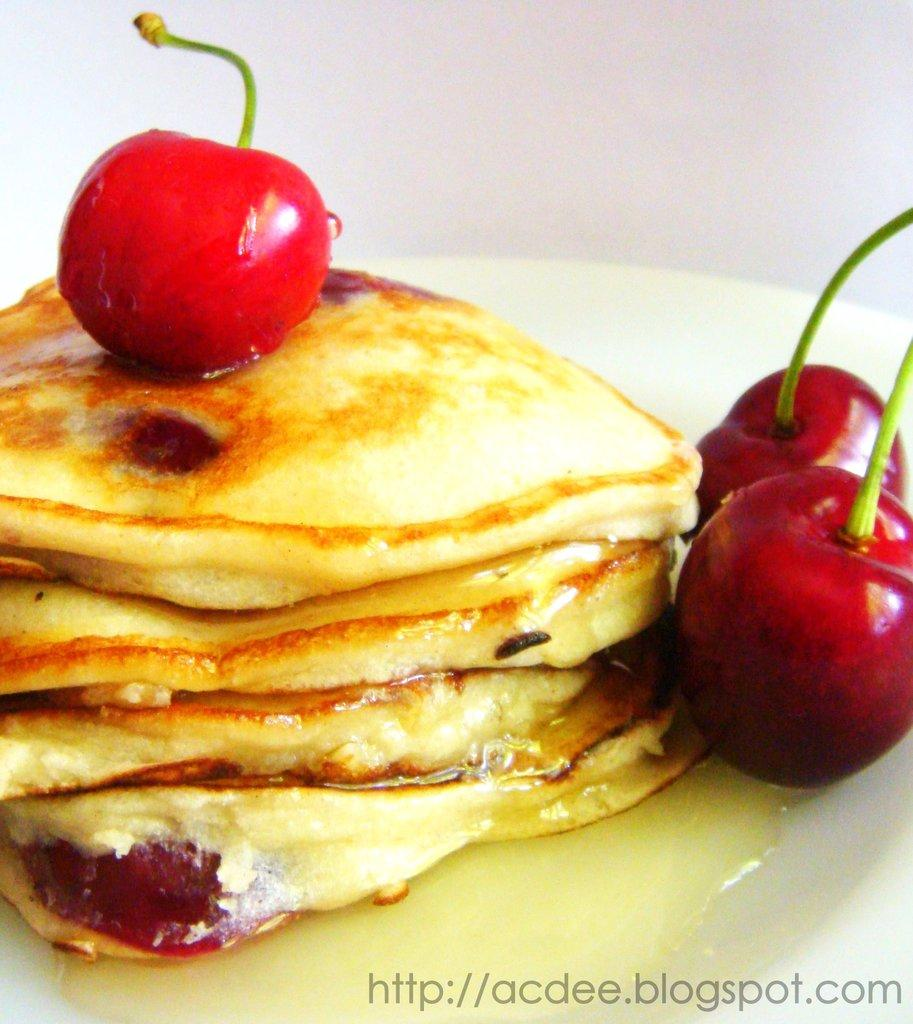What is present on the plate in the image? There are food items served in a plate. Can you describe anything else visible in the image? There is text on the bottom right side of the picture. What type of ground can be seen in the image? There is no ground visible in the image; it only features a plate of food items and text on the bottom right side. 